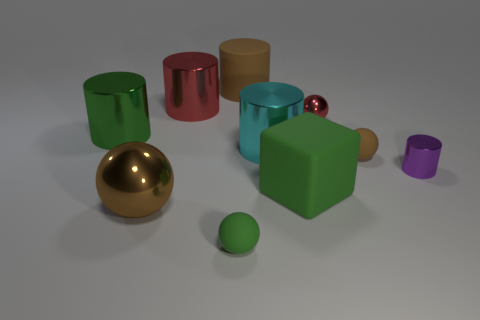Is the tiny purple thing made of the same material as the green sphere?
Give a very brief answer. No. There is a brown ball that is the same size as the purple metal cylinder; what is its material?
Keep it short and to the point. Rubber. How many things are green things to the right of the big brown rubber cylinder or large things?
Ensure brevity in your answer.  6. Are there an equal number of tiny cylinders right of the red shiny sphere and green matte cylinders?
Offer a very short reply. No. Does the large cube have the same color as the tiny metal cylinder?
Provide a short and direct response. No. There is a thing that is behind the green metal object and right of the large matte cylinder; what color is it?
Make the answer very short. Red. How many cylinders are yellow things or rubber things?
Give a very brief answer. 1. Are there fewer tiny green matte objects that are in front of the green matte sphere than tiny purple matte cylinders?
Keep it short and to the point. No. What is the shape of the small red thing that is made of the same material as the green cylinder?
Offer a very short reply. Sphere. What number of big things are the same color as the large block?
Offer a terse response. 1. 